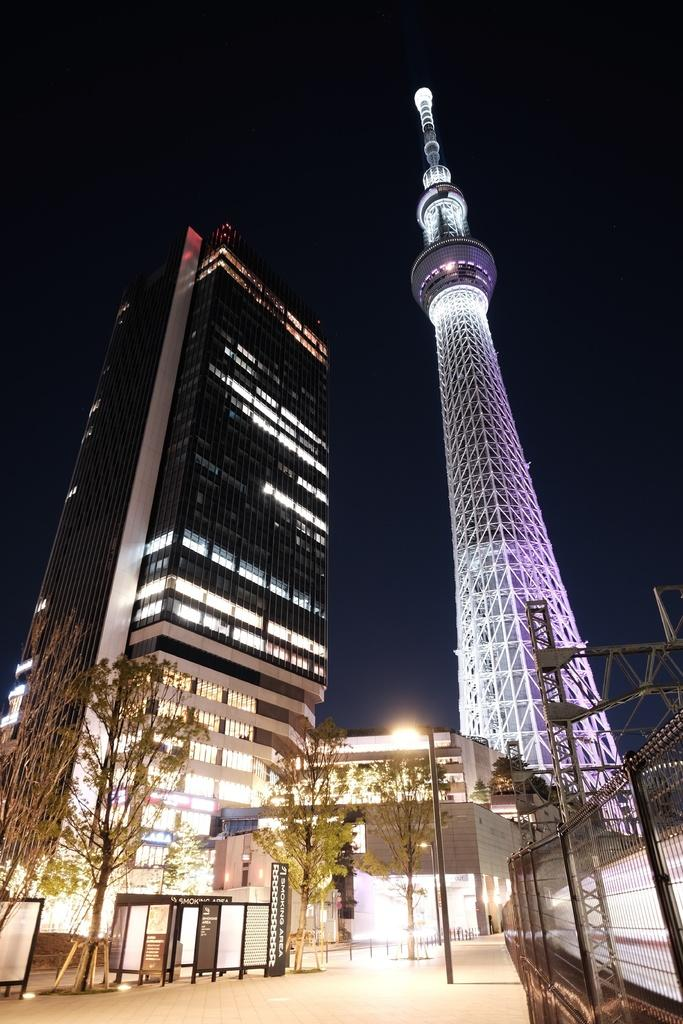What type of structures are visible in the image? There are high rise buildings in the image. What can be seen in front of the buildings? There are trees, lamp posts, and gates in front of the buildings. Can you describe the fence in the image? There is a closed mesh fence in the image. How many bricks can be seen on the cow in the image? There is no cow present in the image, and therefore no bricks can be seen on a cow. 